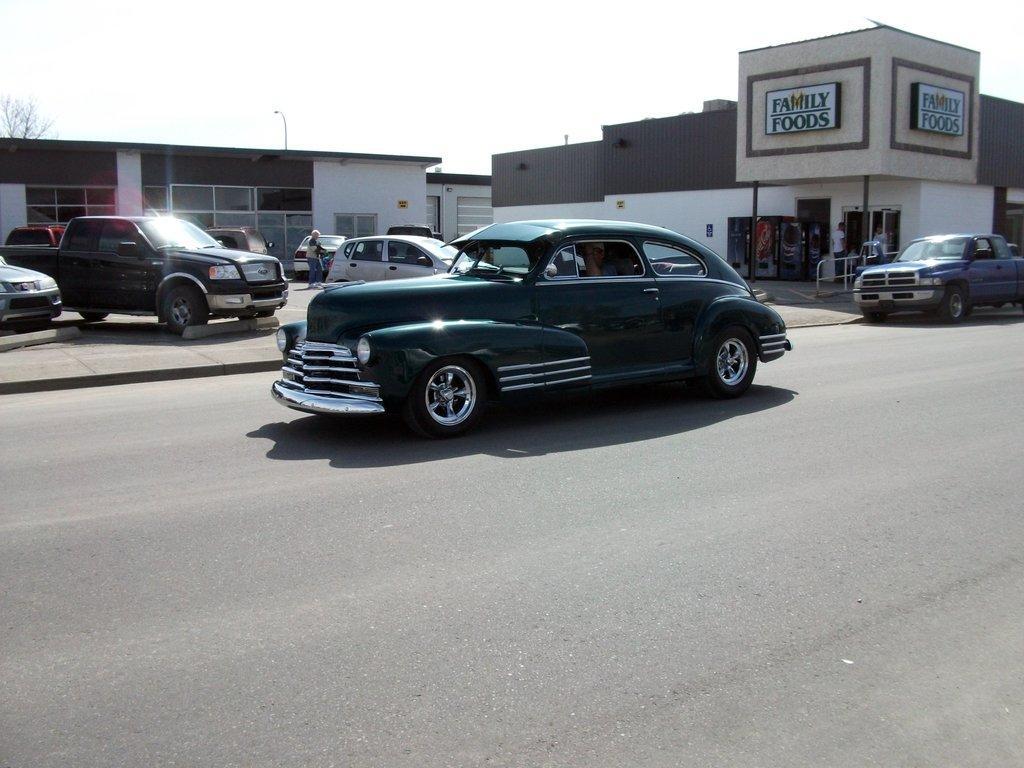Could you give a brief overview of what you see in this image? To the bottom of the image there is a road with two cars. Behind the road there is a parking area with cars. And in the background there are buildings with stores. And stores with glass windows, walls, poles and roof. And also there are trees. And to the top of the image there is a sky. 